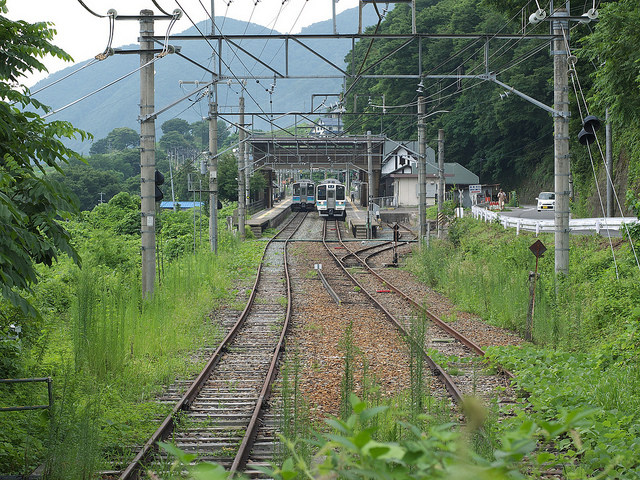There are two trains going down the rail of likely what country?
A. canada
B. united states
C. japan
D. korea The correct answer is C, Japan. The image shows trains that appear similar to those commonly found in Japan, featuring distinct characteristics such as the design and the electrical lines overhead that are typical of Japanese railway systems. 